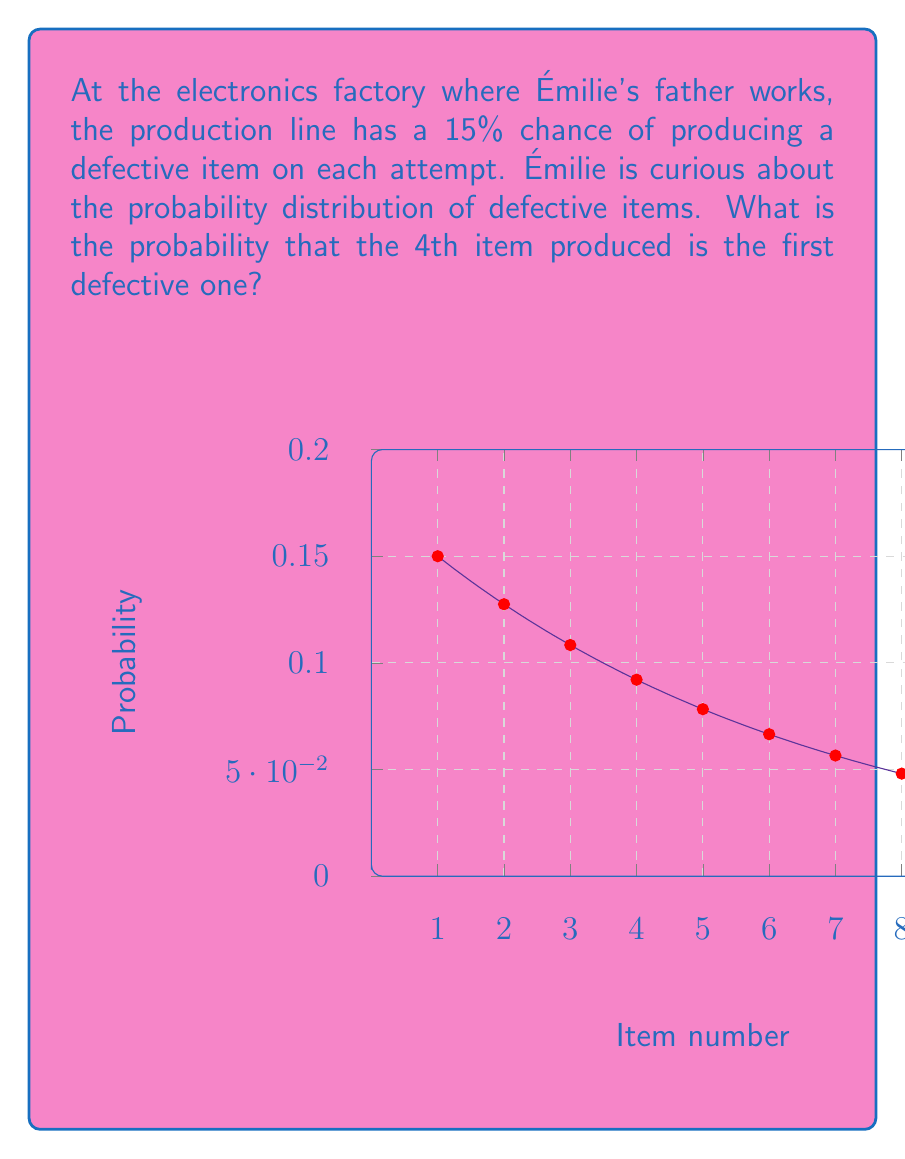Provide a solution to this math problem. To solve this problem, we can use the geometric distribution, which models the number of trials needed to get the first success (in this case, the first defective item).

The probability mass function of the geometric distribution is:

$$P(X = k) = p(1-p)^{k-1}$$

Where:
- $p$ is the probability of success on each trial (probability of a defective item)
- $k$ is the number of trials until the first success

Given:
- $p = 0.15$ (15% chance of a defective item)
- $k = 4$ (we want the 4th item to be the first defective one)

Let's substitute these values into the formula:

$$\begin{align}
P(X = 4) &= 0.15 (1-0.15)^{4-1} \\
&= 0.15 (0.85)^3 \\
&= 0.15 \times 0.614125 \\
&= 0.0921188...
\end{align}$$

Therefore, the probability that the 4th item is the first defective one is approximately 0.0921 or 9.21%.
Answer: $0.0921$ or $9.21\%$ 